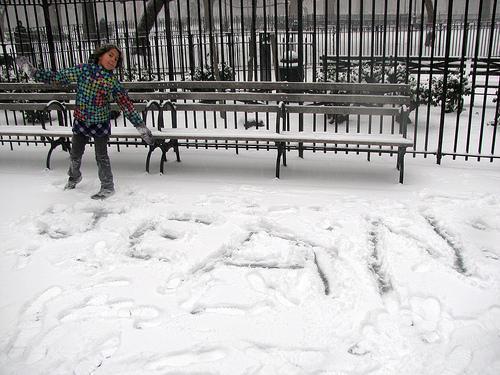How many children are there?
Give a very brief answer. 1. How many people are shown?
Give a very brief answer. 1. How many animals are shown?
Give a very brief answer. 0. How many letters are written in the snow in the image?
Give a very brief answer. 4. 